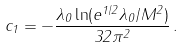Convert formula to latex. <formula><loc_0><loc_0><loc_500><loc_500>c _ { 1 } = - \frac { \lambda _ { 0 } \ln ( e ^ { 1 / 2 } \lambda _ { 0 } / M ^ { 2 } ) } { 3 2 \pi ^ { 2 } } \, .</formula> 